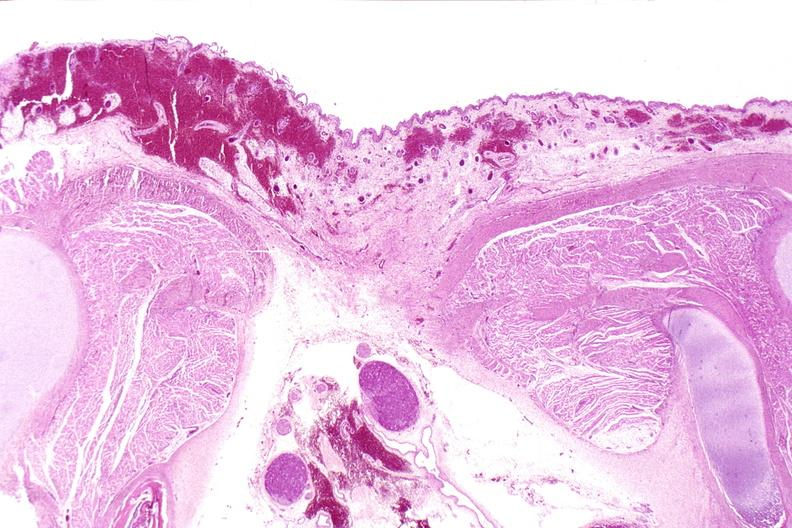what is present?
Answer the question using a single word or phrase. Nervous 